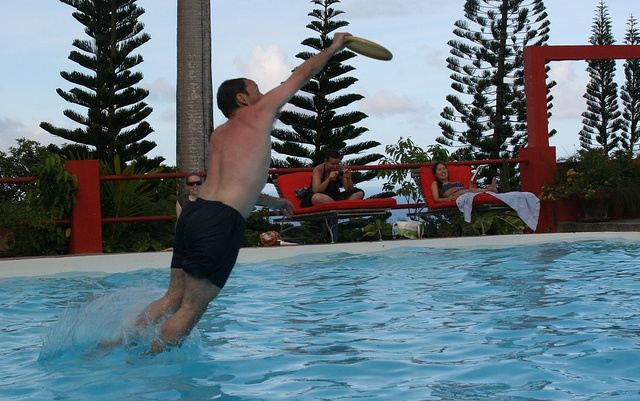Describe the objects in this image and their specific colors. I can see people in lightblue, black, gray, brown, and maroon tones, chair in lightblue, black, maroon, and gray tones, chair in lightblue, black, maroon, and gray tones, people in lightblue, black, maroon, and brown tones, and people in lightblue, maroon, black, and brown tones in this image. 